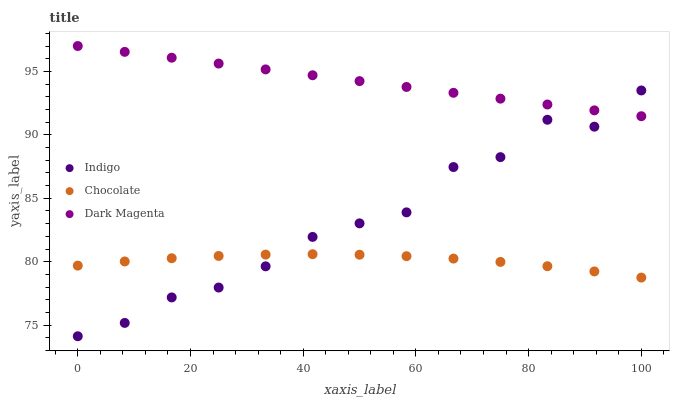Does Chocolate have the minimum area under the curve?
Answer yes or no. Yes. Does Dark Magenta have the maximum area under the curve?
Answer yes or no. Yes. Does Dark Magenta have the minimum area under the curve?
Answer yes or no. No. Does Chocolate have the maximum area under the curve?
Answer yes or no. No. Is Dark Magenta the smoothest?
Answer yes or no. Yes. Is Indigo the roughest?
Answer yes or no. Yes. Is Chocolate the smoothest?
Answer yes or no. No. Is Chocolate the roughest?
Answer yes or no. No. Does Indigo have the lowest value?
Answer yes or no. Yes. Does Chocolate have the lowest value?
Answer yes or no. No. Does Dark Magenta have the highest value?
Answer yes or no. Yes. Does Chocolate have the highest value?
Answer yes or no. No. Is Chocolate less than Dark Magenta?
Answer yes or no. Yes. Is Dark Magenta greater than Chocolate?
Answer yes or no. Yes. Does Indigo intersect Chocolate?
Answer yes or no. Yes. Is Indigo less than Chocolate?
Answer yes or no. No. Is Indigo greater than Chocolate?
Answer yes or no. No. Does Chocolate intersect Dark Magenta?
Answer yes or no. No. 